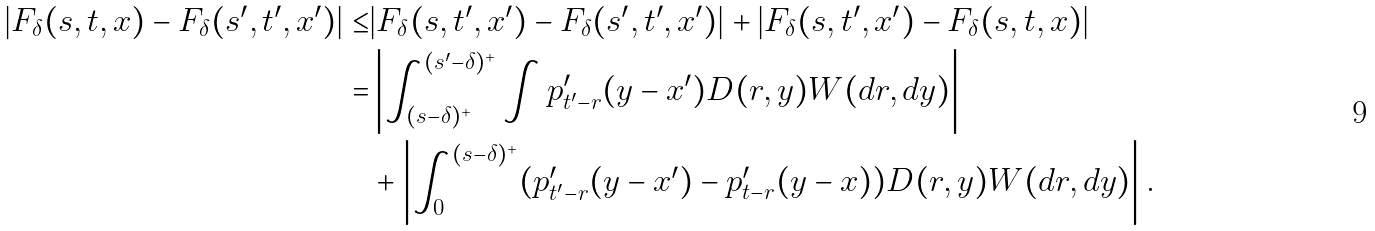<formula> <loc_0><loc_0><loc_500><loc_500>| F _ { \delta } ( s , t , x ) - F _ { \delta } ( s ^ { \prime } , t ^ { \prime } , x ^ { \prime } ) | \leq & | F _ { \delta } ( s , t ^ { \prime } , x ^ { \prime } ) - F _ { \delta } ( s ^ { \prime } , t ^ { \prime } , x ^ { \prime } ) | + | F _ { \delta } ( s , t ^ { \prime } , x ^ { \prime } ) - F _ { \delta } ( s , t , x ) | \\ = & \left | \int _ { ( s - \delta ) ^ { + } } ^ { ( s ^ { \prime } - \delta ) ^ { + } } \int p ^ { \prime } _ { t ^ { \prime } - r } ( y - x ^ { \prime } ) D ( r , y ) W ( d r , d y ) \right | \\ & + \left | \int _ { 0 } ^ { ( s - \delta ) ^ { + } } ( p ^ { \prime } _ { t ^ { \prime } - r } ( y - x ^ { \prime } ) - p ^ { \prime } _ { t - r } ( y - x ) ) D ( r , y ) W ( d r , d y ) \right | .</formula> 